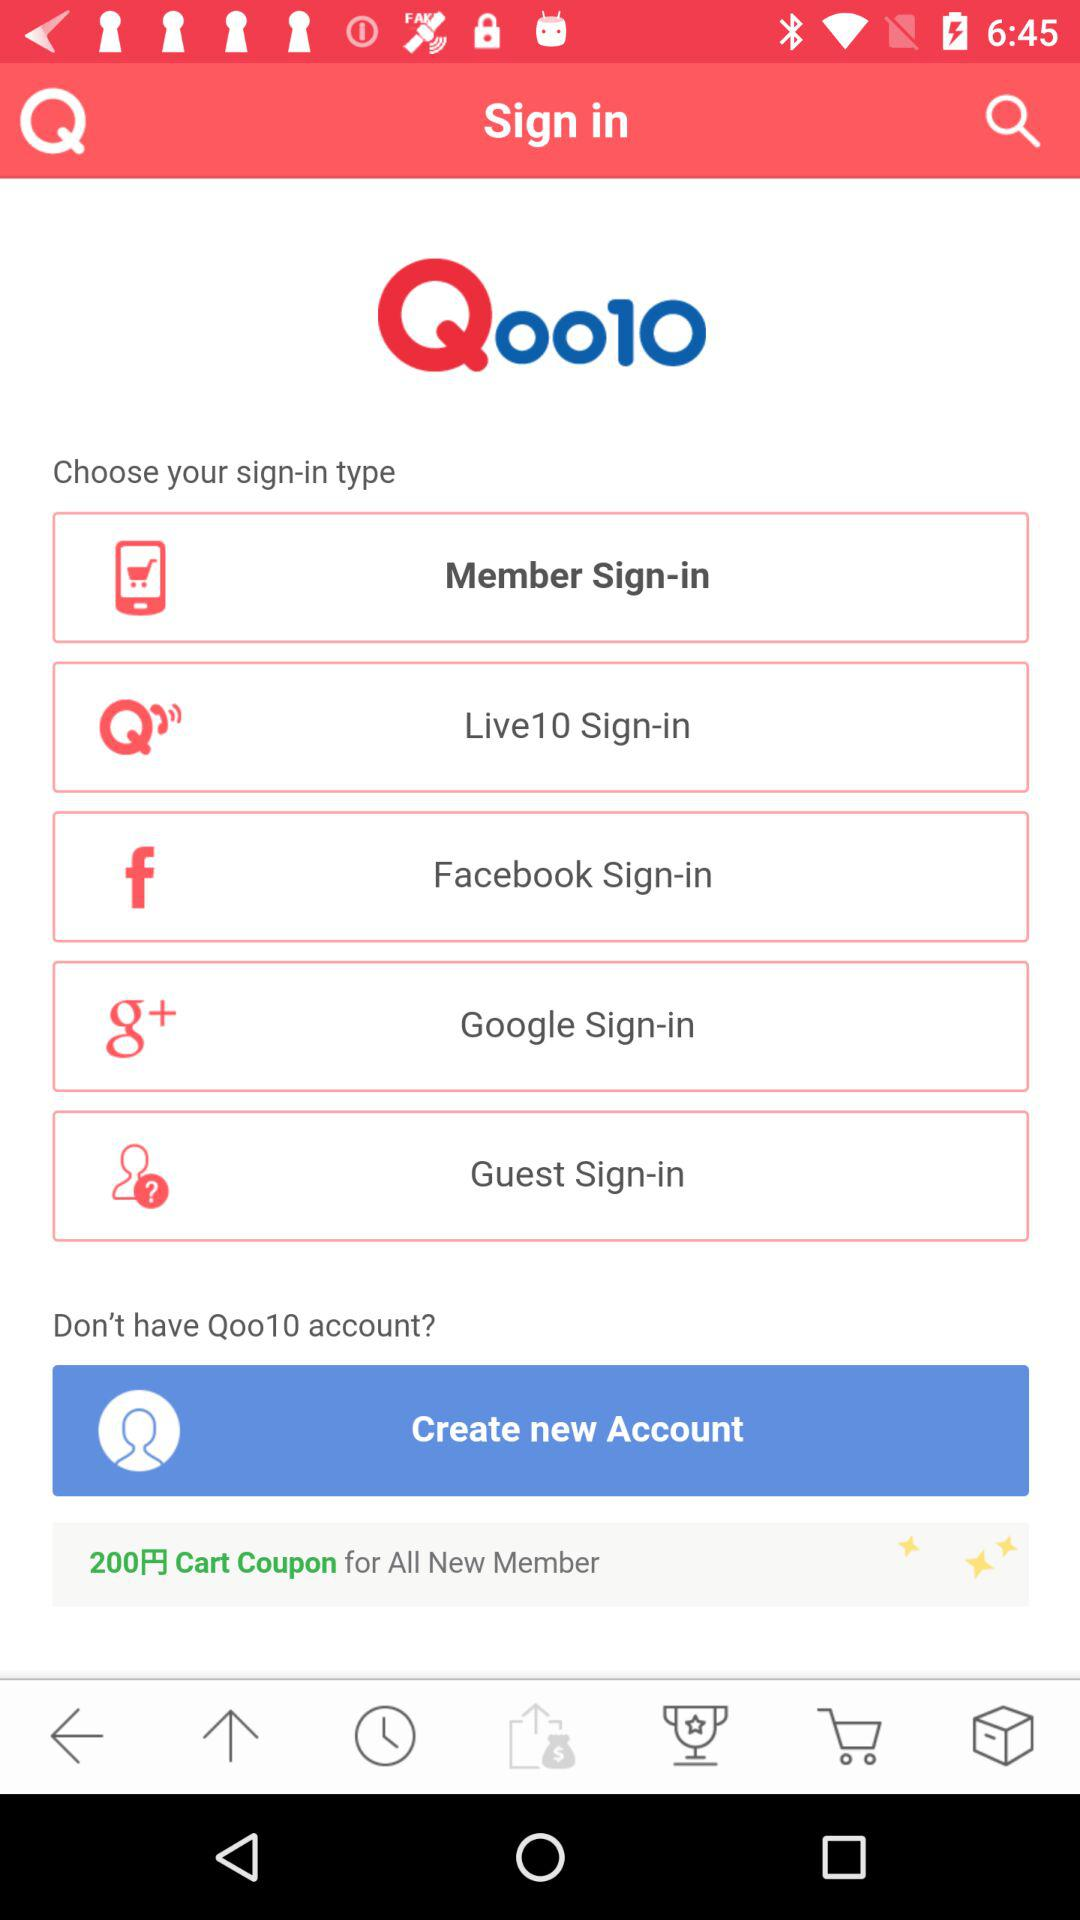Which application can be used to sign in? The applications that can be used to sign in are "Live 10", "Facebook" and "Google". 